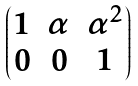Convert formula to latex. <formula><loc_0><loc_0><loc_500><loc_500>\begin{pmatrix} 1 & \alpha & \alpha ^ { 2 } \\ 0 & 0 & 1 \end{pmatrix}</formula> 